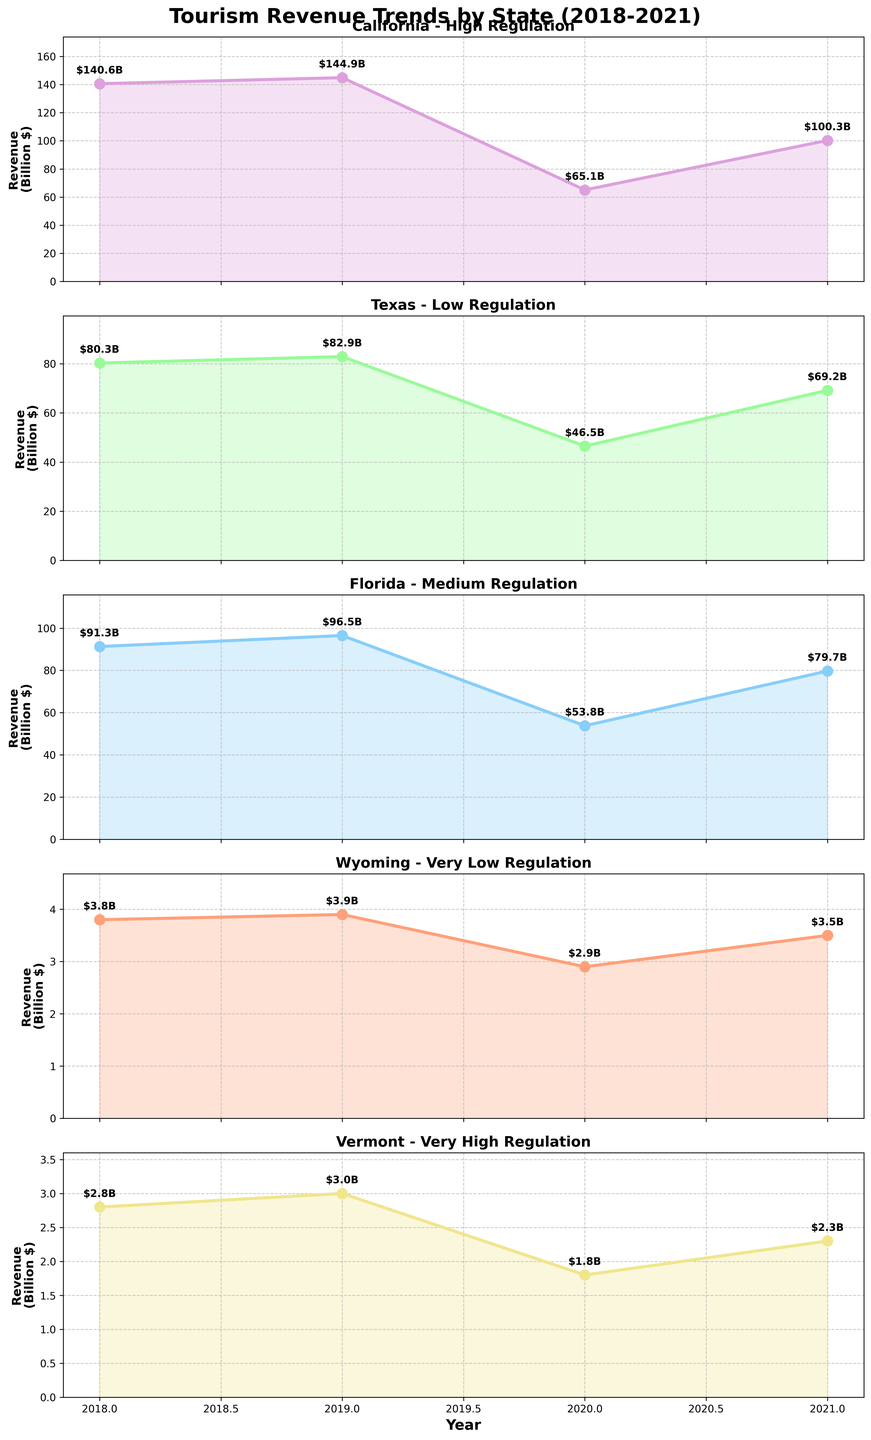What state has the highest tourism revenue in 2020? Looking at the 2020 data points on each subplot, California has a visually higher tourism revenue ($65.1 billion) compared to other states.
Answer: California How does Vermont’s tourism revenue in 2020 compare to 2021? Inspecting Vermont's subplot, tourism revenue in 2020 was $1.8 billion while in 2021 it was $2.3 billion. The revenue increased by $0.5 billion in 2021.
Answer: Increased by $0.5 billion What is the total tourism revenue for Florida from 2018 to 2021? Adding up the values from Florida's subplot: $91.3B (2018) + $96.5B (2019) + $53.8B (2020) + $79.7B (2021), the total sum is $321.3 billion.
Answer: $321.3 billion Which year shows the highest revenue drop for Texas? Observing the Texas subplot, the largest revenue drop occurred between 2019 ($82.9B) and 2020 ($46.5B). The difference is $36.4 billion.
Answer: 2019 to 2020 How does Wyoming's revenue trend compare to the other states? Wyoming shows the least amount of tourism revenue and also the smallest fluctuations, maintaining a relatively stable trend with slight decreases and increases.
Answer: Smallest fluctuations In which state did tourism revenue rebound the quickest post-2020? Comparing the subplots, California's revenue rebounded from $65.1 billion in 2020 to $100.3 billion in 2021, an increase of $35.2 billion, which is visually more substantial compared to other states.
Answer: California What visual element indicates the environmental regulation level for each state? The color of the line and shaded area in each subplot represents the environmental regulation level, with unique colors for each level.
Answer: Line and shaded area colors Which state and year had the lowest tourism revenue? Wyoming in 2020 had the lowest tourism revenue at $2.9 billion, as visible on its subplot.
Answer: Wyoming, 2020 What trend is observable in Texas's tourism revenue from 2018 to 2021? Texas's revenue shows a peak in 2019 followed by a significant drop in 2020 and an increase in 2021, indicating a U-shaped trend.
Answer: U-shaped trend By how much did California's tourism revenue differ from 2019 to 2020? Calculating the difference: $144.9B (2019) - $65.1B (2020) = $79.8 billion.
Answer: $79.8 billion 